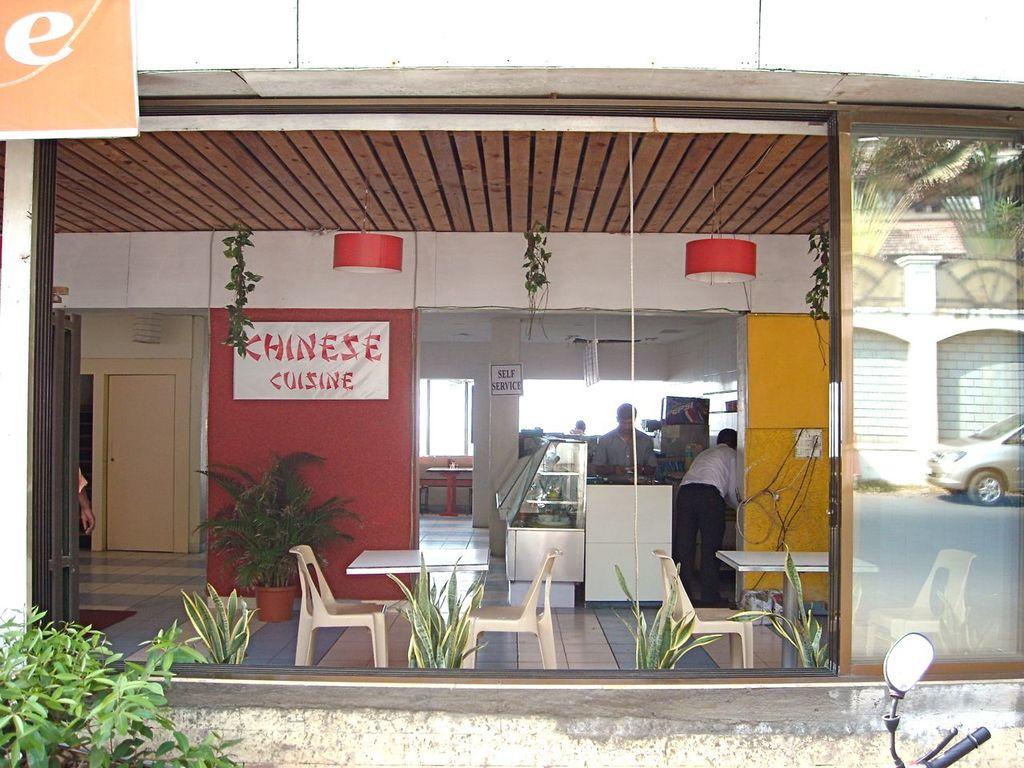Please provide a concise description of this image. In this image we can see one building, two lights attached to the ceiling, some objects are on the surface, some plants are on the surface, some boards with some text, some objects are on the table, one banner, some people are there, one person hand, some chairs, some wires, one glass door, one person hand, one vehicle mirror, one car on the road, one door, one white wall, on staircase and some objects are on the wall. 